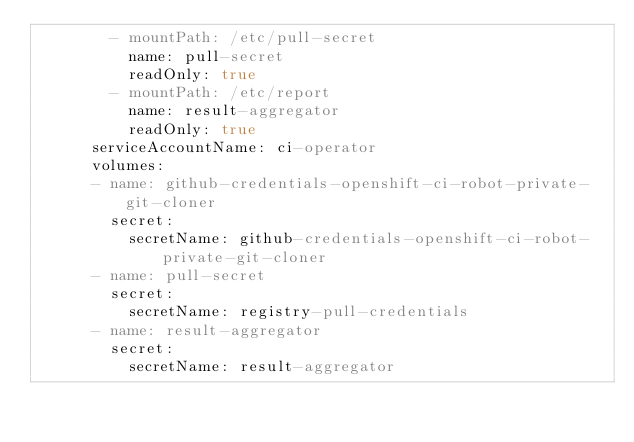Convert code to text. <code><loc_0><loc_0><loc_500><loc_500><_YAML_>        - mountPath: /etc/pull-secret
          name: pull-secret
          readOnly: true
        - mountPath: /etc/report
          name: result-aggregator
          readOnly: true
      serviceAccountName: ci-operator
      volumes:
      - name: github-credentials-openshift-ci-robot-private-git-cloner
        secret:
          secretName: github-credentials-openshift-ci-robot-private-git-cloner
      - name: pull-secret
        secret:
          secretName: registry-pull-credentials
      - name: result-aggregator
        secret:
          secretName: result-aggregator
</code> 